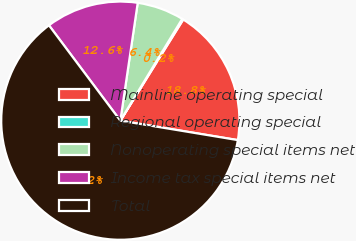Convert chart. <chart><loc_0><loc_0><loc_500><loc_500><pie_chart><fcel>Mainline operating special<fcel>Regional operating special<fcel>Nonoperating special items net<fcel>Income tax special items net<fcel>Total<nl><fcel>18.76%<fcel>0.16%<fcel>6.36%<fcel>12.56%<fcel>62.16%<nl></chart> 